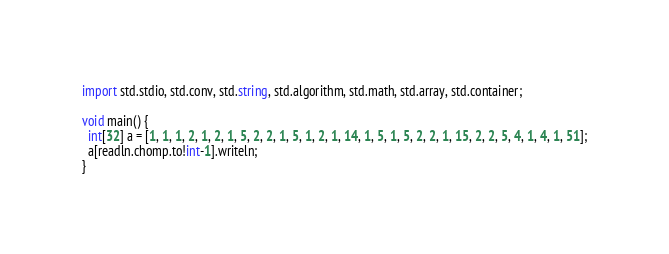Convert code to text. <code><loc_0><loc_0><loc_500><loc_500><_D_>import std.stdio, std.conv, std.string, std.algorithm, std.math, std.array, std.container;

void main() {
  int[32] a = [1, 1, 1, 2, 1, 2, 1, 5, 2, 2, 1, 5, 1, 2, 1, 14, 1, 5, 1, 5, 2, 2, 1, 15, 2, 2, 5, 4, 1, 4, 1, 51];
  a[readln.chomp.to!int-1].writeln;
}

</code> 